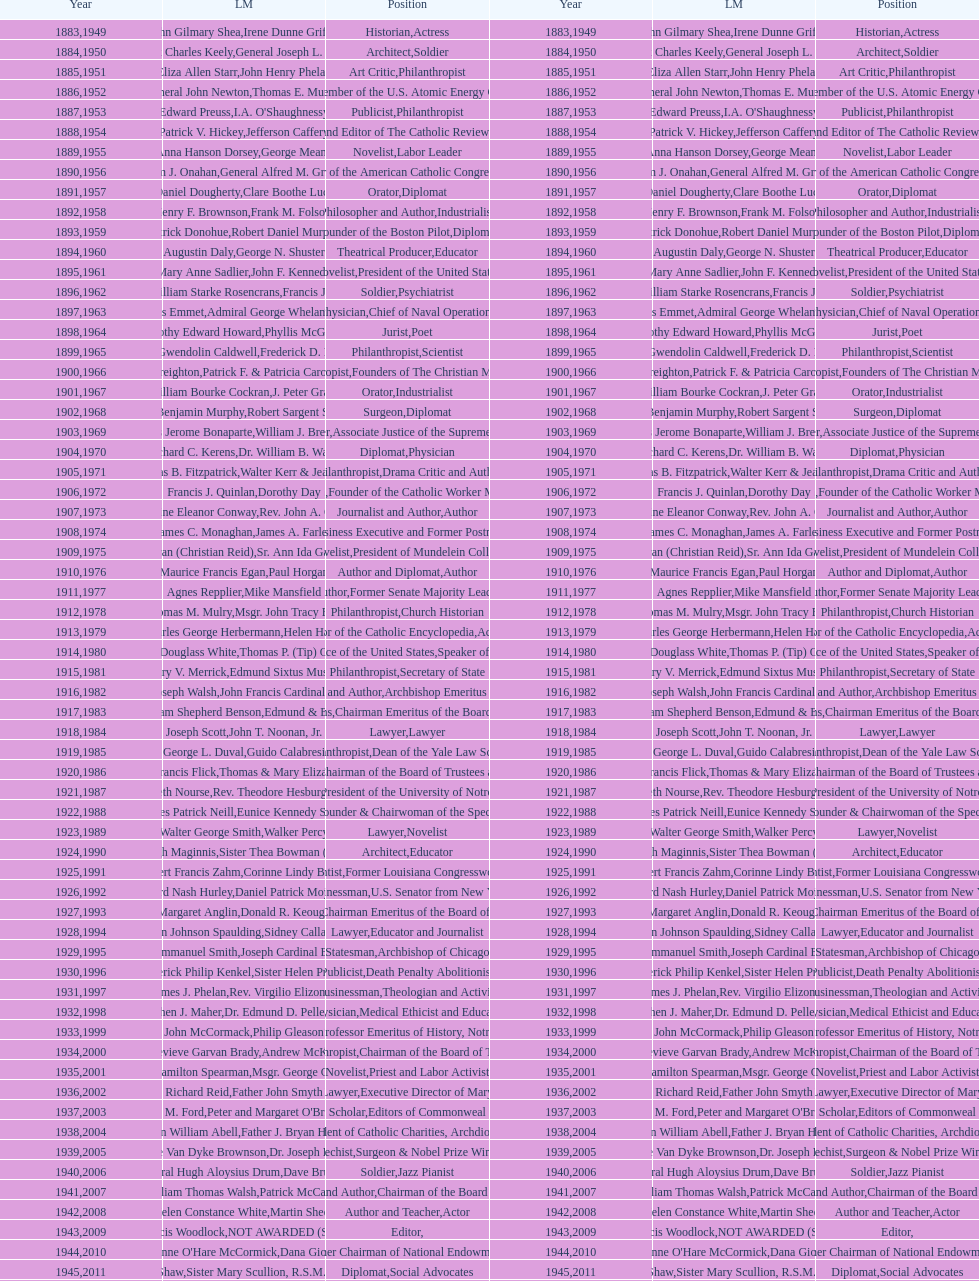How many times does philanthropist appear in the position column on this chart? 9. 